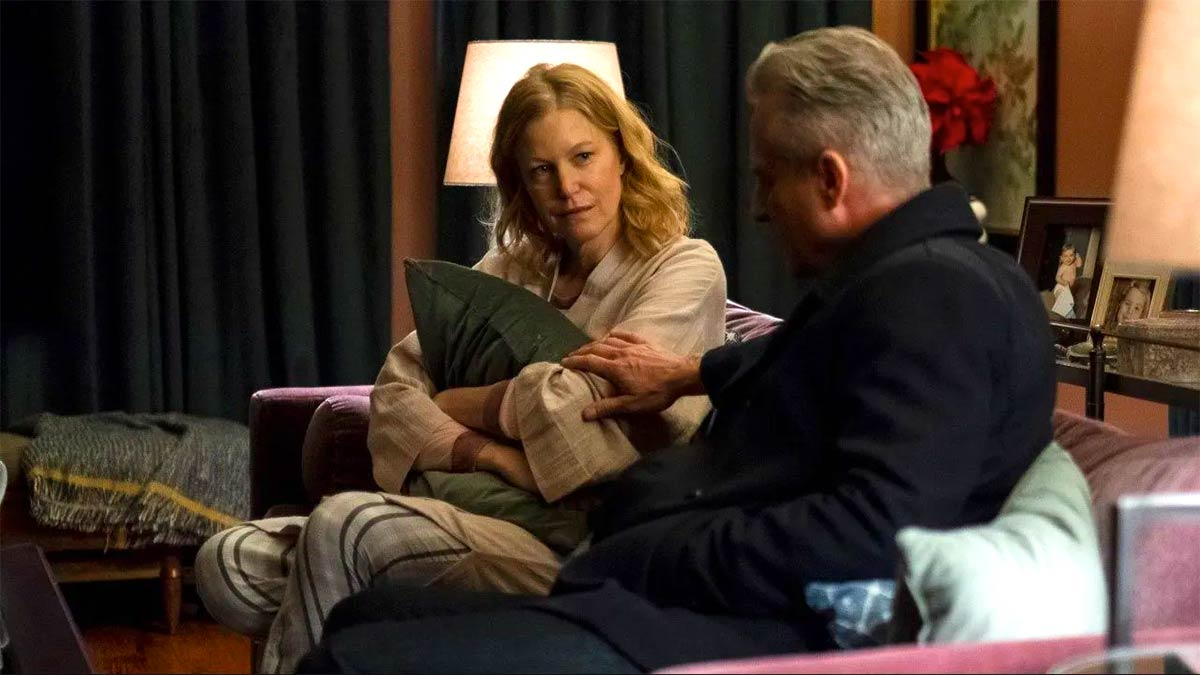Imagine a backstory for these characters. The woman, let’s call her Sarah, might be a middle-aged professional who recently faced a significant challenge at work or in her personal life. The man, named Mark, could be her long-time friend or possibly her brother who has come over to offer support. They grew up in a small town and have shared a close bond since childhood. Sarah, finding herself at a crossroads, might be confiding in Mark about a critical decision she needs to make, seeking his wisdom and comfort during this difficult time. Their relationship is built on mutual respect and a deep understanding of each other’s journeys. Can you create a dialogue between them? Sarah: 'I don’t know what to do, Mark. It feels like everything is slipping through my fingers.'

Mark: 'Hey, it's okay, Sarah. I’m here for you. Let's talk through it together. What’s weighing you down the most?' 

Sarah: 'It’s just… everything. Work has been overwhelming and I feel like I’m falling behind. And at home, it’s like I’m failing to be present for the kids.'

Mark: 'You’re not alone in this. We all have moments when things seem insurmountable. Let’s break it down. What's happening at work?' 

Sarah: 'I’ve been given this huge project and it’s just too much. I’m scared I’ll mess it up and let everyone down.'

Mark: 'Sarah, you’re one of the most capable people I know. Let’s figure out a plan to manage it step by step. You’ve got this, and we’ll get through it together.' 